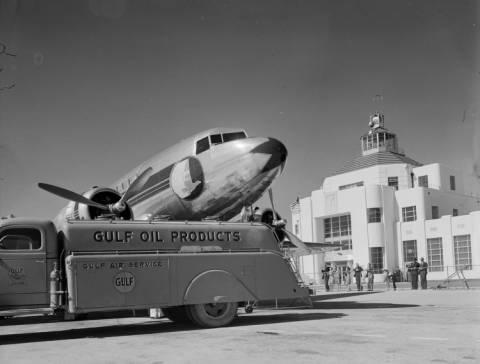What do they deliver?
Be succinct. Oil. IS this in an airport terminal?
Answer briefly. No. How many exhaust pipes does the truck have?
Short answer required. 1. What kind of company is this on the truck?
Answer briefly. Oil. What type of plane is pictured?
Concise answer only. Passenger. How many plane propellers in this picture?
Write a very short answer. 2. What time period was this taken?
Write a very short answer. 1940's. What type of vehicle is closest to the camera?
Short answer required. Truck. What word is on the front?
Concise answer only. Gulf. 